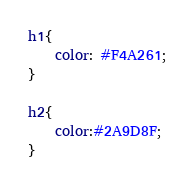<code> <loc_0><loc_0><loc_500><loc_500><_CSS_>h1{
    color: #F4A261;
}

h2{
    color:#2A9D8F;
}</code> 